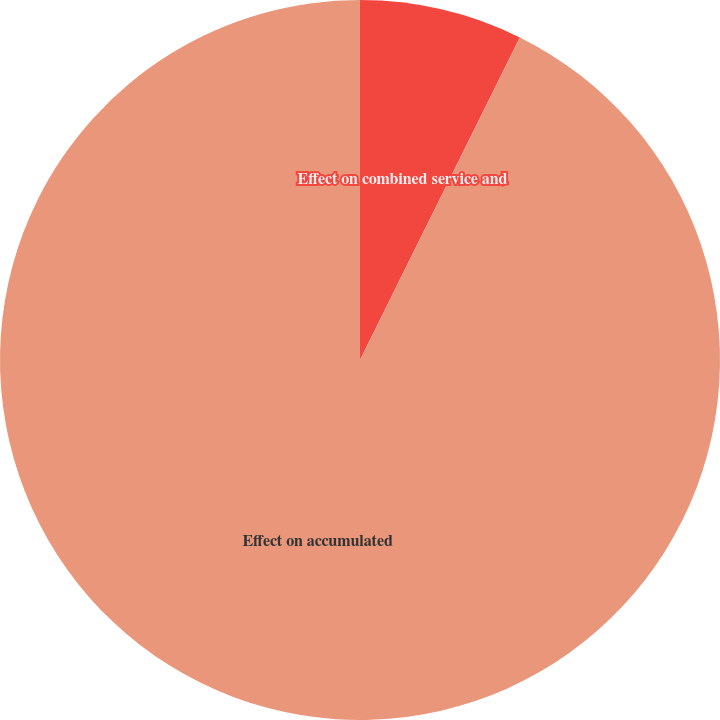Convert chart to OTSL. <chart><loc_0><loc_0><loc_500><loc_500><pie_chart><fcel>Effect on combined service and<fcel>Effect on accumulated<nl><fcel>7.32%<fcel>92.68%<nl></chart> 